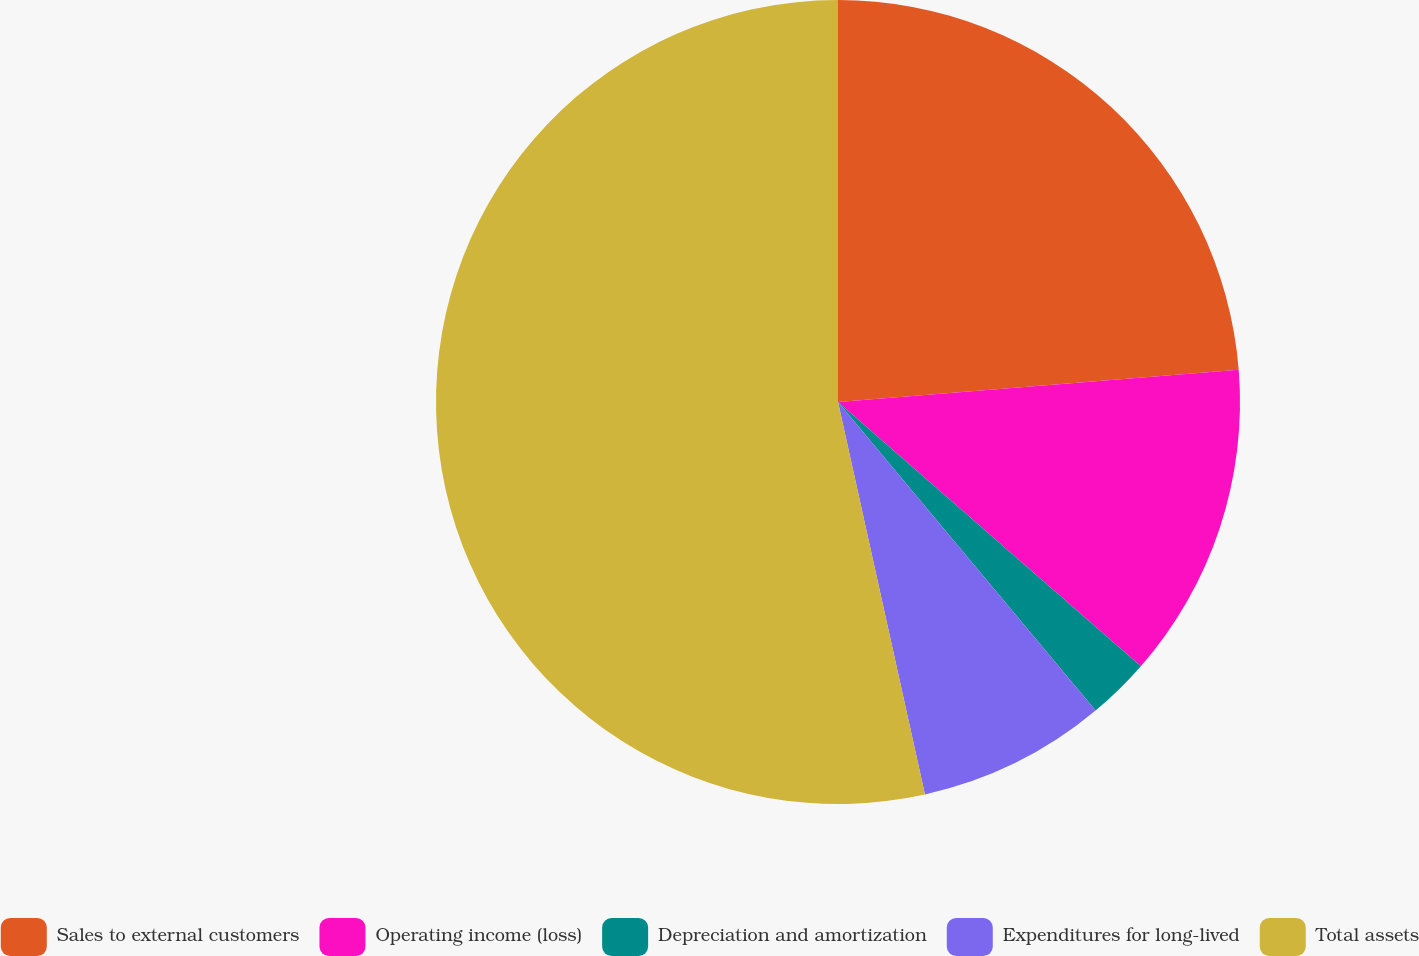Convert chart. <chart><loc_0><loc_0><loc_500><loc_500><pie_chart><fcel>Sales to external customers<fcel>Operating income (loss)<fcel>Depreciation and amortization<fcel>Expenditures for long-lived<fcel>Total assets<nl><fcel>23.72%<fcel>12.7%<fcel>2.51%<fcel>7.6%<fcel>53.47%<nl></chart> 